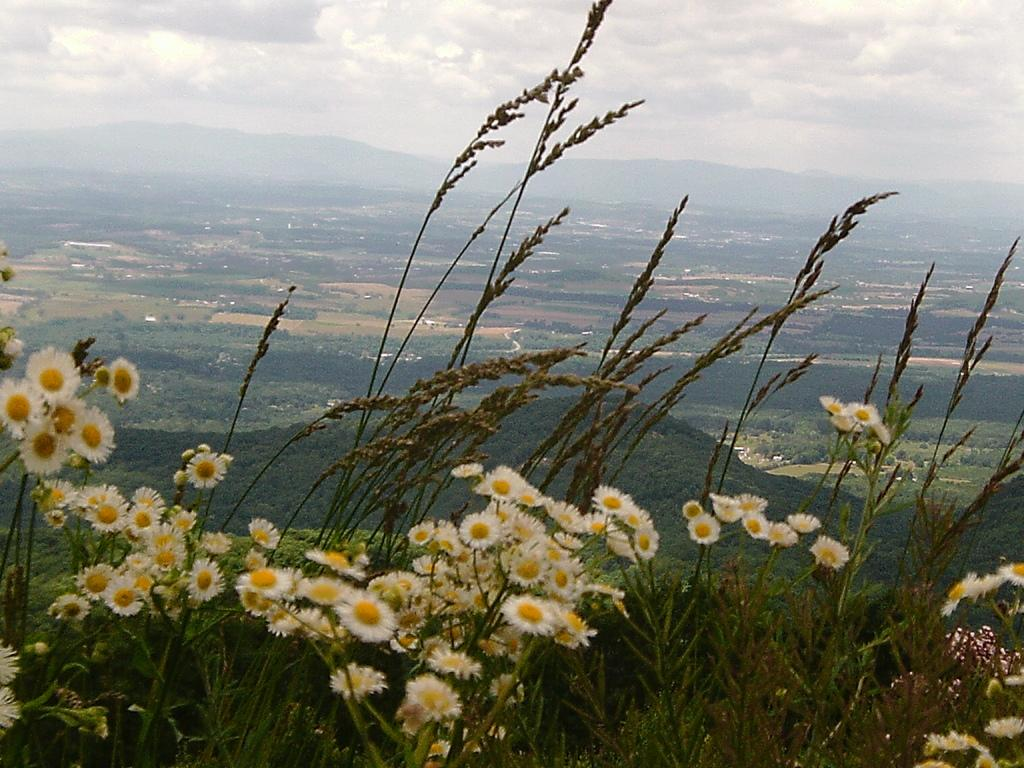What is the setting of the image? The image has an outside view. What can be seen in the foreground of the image? There are plants in the foreground of the image. What is visible at the top of the image? The sky is visible at the top of the image. Can you see the minister playing volleyball with the goldfish in the image? There is no minister, volleyball, or goldfish present in the image. 